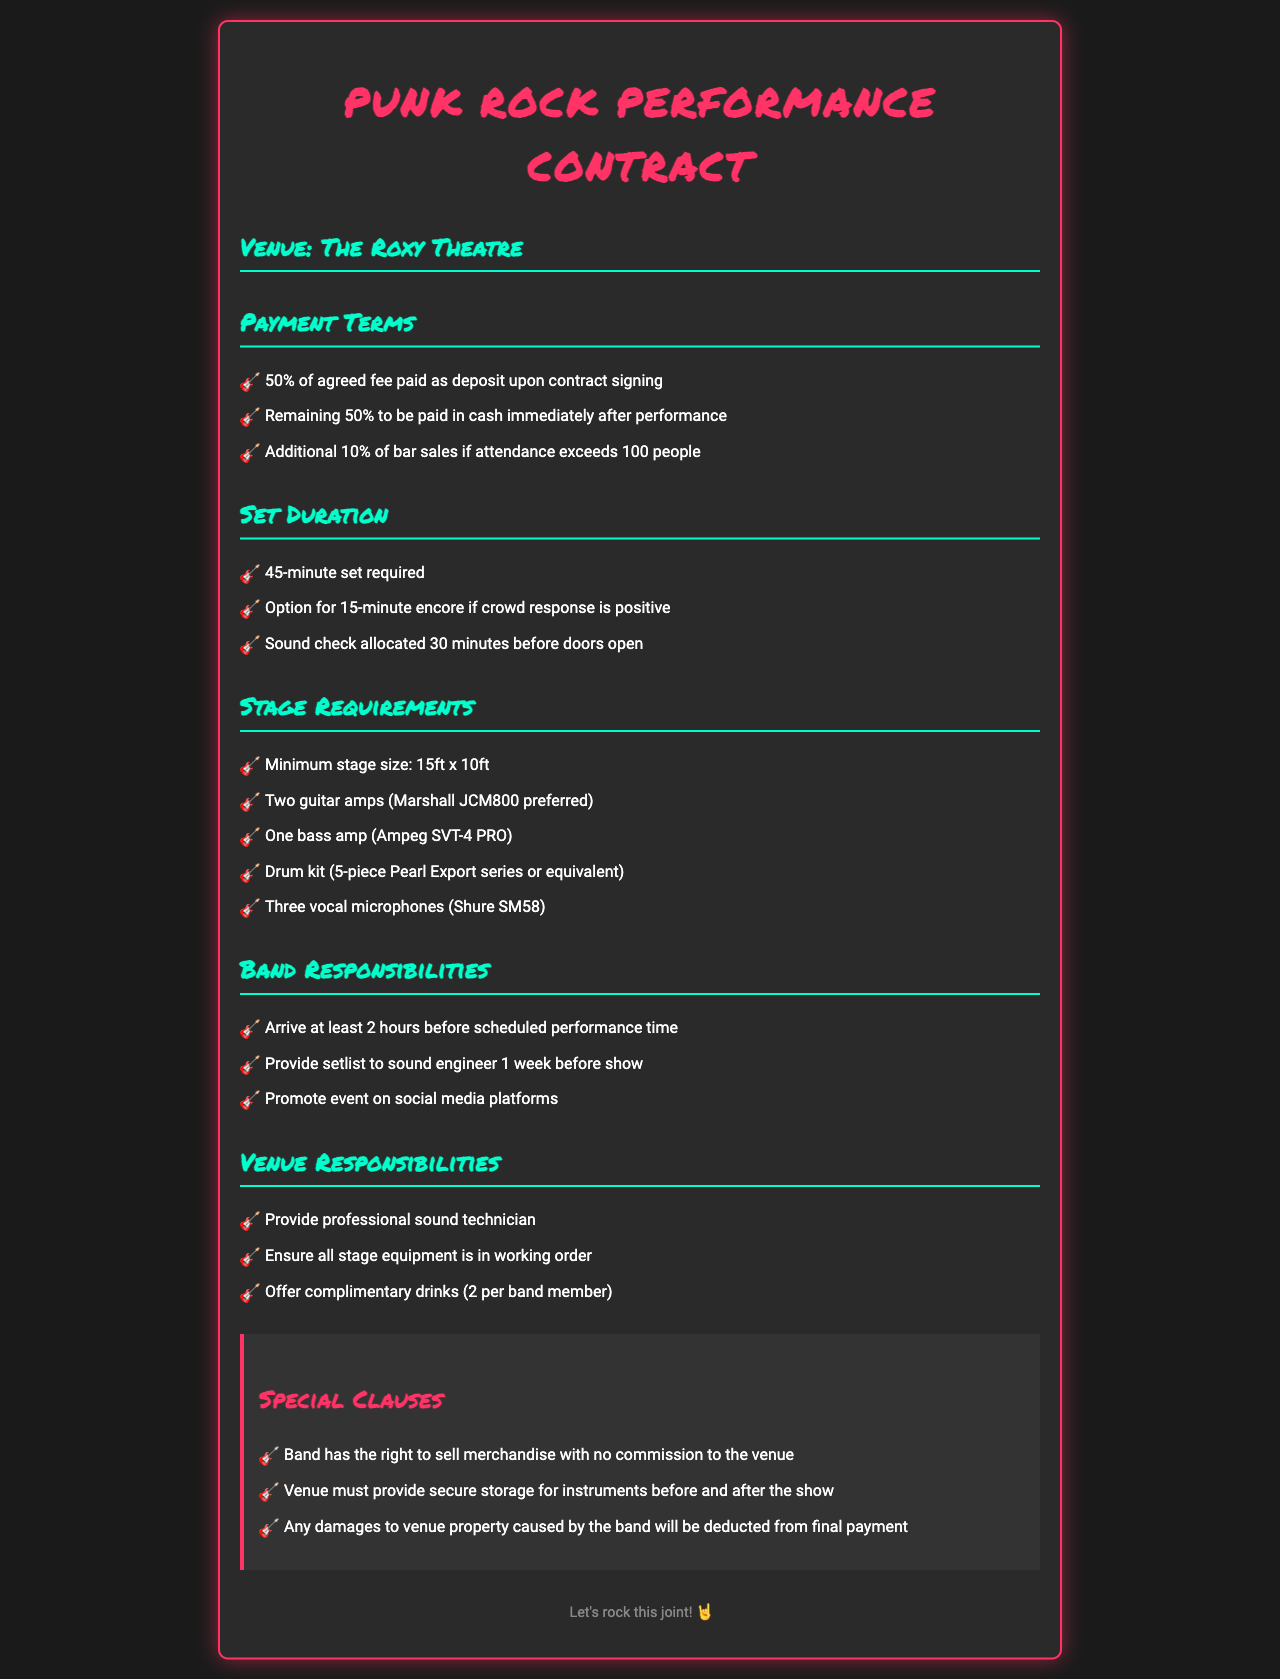What is the deposit percentage? The deposit percentage as per the payment terms is specified as 50% of the agreed fee.
Answer: 50% How long is the set duration? The set duration required for the performance is given as 45 minutes.
Answer: 45-minute What is the stage size requirement? The minimum stage size requirement is mentioned in the stage requirements section, which is specified as 15ft x 10ft.
Answer: 15ft x 10ft What type of vocal microphones are required? The required type of vocal microphones for the performance is specified as Shure SM58.
Answer: Shure SM58 What happens if attendance exceeds 100 people? If attendance exceeds 100 people, the band is entitled to an additional 10% of bar sales.
Answer: Additional 10% of bar sales How many hours before the performance should the band arrive? The document states that the band should arrive at least 2 hours before the scheduled performance time.
Answer: 2 hours What is required for a successful encore? The option for a 15-minute encore is dependent on a positive crowd response.
Answer: Positive crowd response What must the venue provide for the band? Among several responsibilities, the venue must provide a professional sound technician for the performance.
Answer: Professional sound technician Is there a commission for merchandise sales? The document specifies that the band has the right to sell merchandise with no commission to the venue.
Answer: No commission 